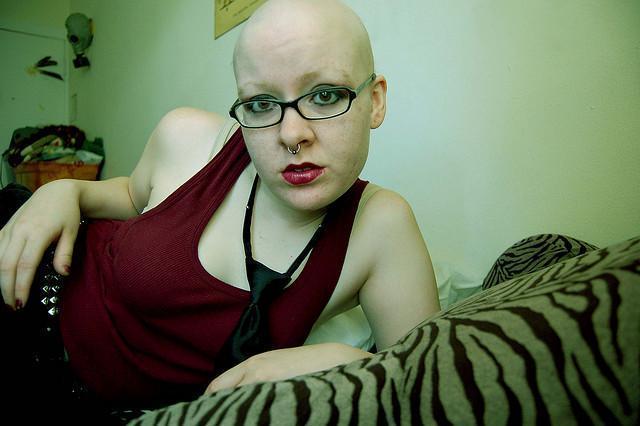How many faces can be seen?
Give a very brief answer. 1. 